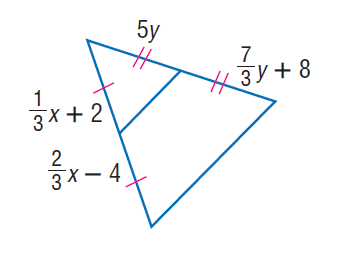Answer the mathemtical geometry problem and directly provide the correct option letter.
Question: Find y.
Choices: A: 2.2 B: 3 C: 5 D: 6 B 